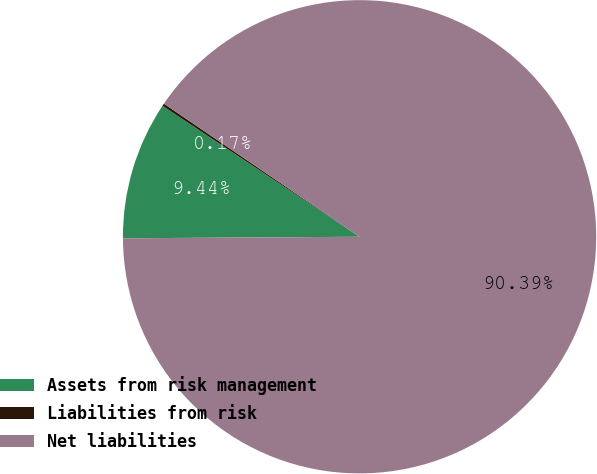Convert chart to OTSL. <chart><loc_0><loc_0><loc_500><loc_500><pie_chart><fcel>Assets from risk management<fcel>Liabilities from risk<fcel>Net liabilities<nl><fcel>9.44%<fcel>0.17%<fcel>90.39%<nl></chart> 